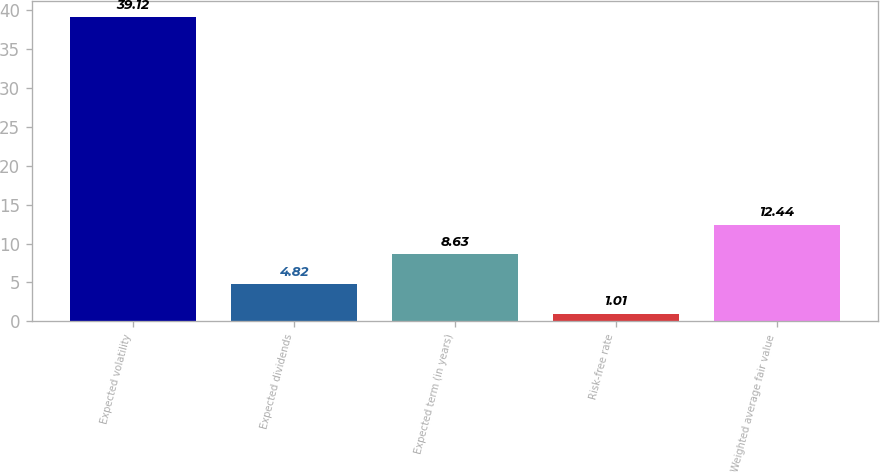Convert chart. <chart><loc_0><loc_0><loc_500><loc_500><bar_chart><fcel>Expected volatility<fcel>Expected dividends<fcel>Expected term (in years)<fcel>Risk-free rate<fcel>Weighted average fair value<nl><fcel>39.12<fcel>4.82<fcel>8.63<fcel>1.01<fcel>12.44<nl></chart> 